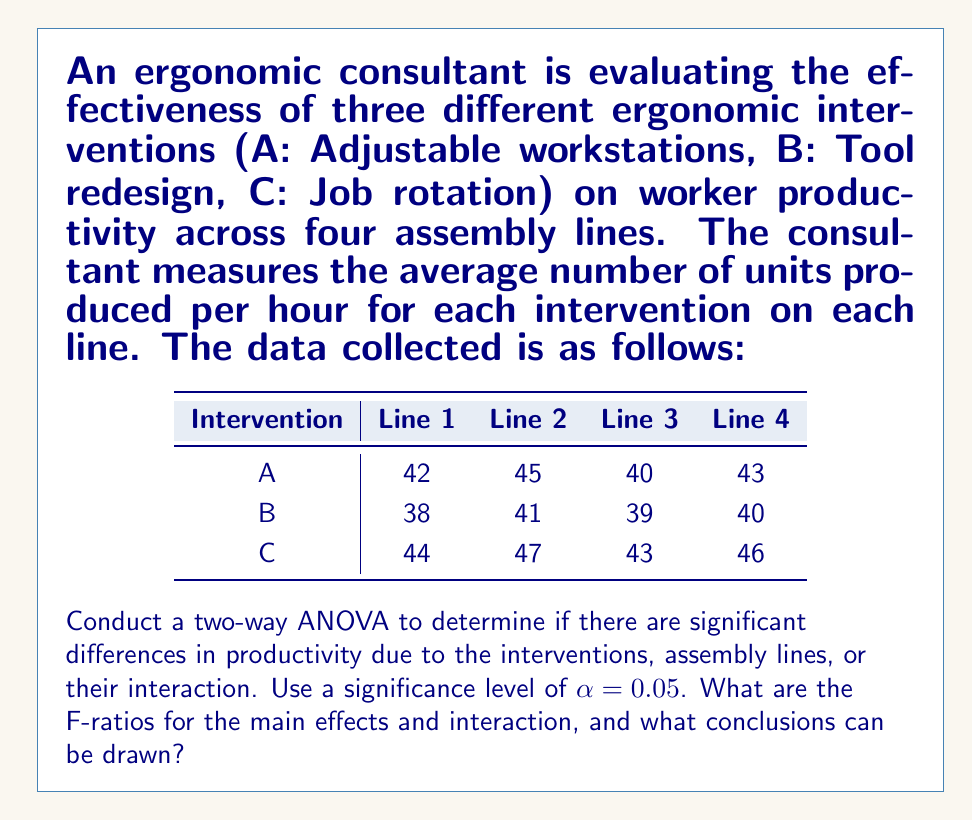What is the answer to this math problem? To conduct a two-way ANOVA, we need to calculate the sum of squares (SS) for each factor (intervention and assembly line), their interaction, and the error. Then, we'll compute the mean squares (MS) and F-ratios.

Step 1: Calculate the grand mean
$$\bar{X} = \frac{538}{12} = 44.83$$

Step 2: Calculate SS for interventions (SSA)
$$SSA = 4 \sum_{i=1}^{3} (\bar{X}_i - \bar{X})^2 = 4[(42.5 - 44.83)^2 + (39.5 - 44.83)^2 + (45 - 44.83)^2] = 121$$

Step 3: Calculate SS for assembly lines (SSB)
$$SSB = 3 \sum_{j=1}^{4} (\bar{X}_j - \bar{X})^2 = 3[(41.33 - 44.83)^2 + (44.33 - 44.83)^2 + (40.67 - 44.83)^2 + (43 - 44.83)^2] = 30$$

Step 4: Calculate SS for interaction (SSAB)
$$SSAB = \sum_{i=1}^{3} \sum_{j=1}^{4} (X_{ij} - \bar{X}_i - \bar{X}_j + \bar{X})^2 = 2$$

Step 5: Calculate total SS (SST)
$$SST = \sum_{i=1}^{3} \sum_{j=1}^{4} (X_{ij} - \bar{X})^2 = 157$$

Step 6: Calculate SS for error (SSE)
$$SSE = SST - SSA - SSB - SSAB = 157 - 121 - 30 - 2 = 4$$

Step 7: Create ANOVA table and calculate F-ratios

$$
\begin{array}{lccccc}
\text{Source} & \text{df} & \text{SS} & \text{MS} & \text{F} & \text{F critical} \\
\hline
\text{Intervention} & 2 & 121 & 60.5 & 30.25 & 5.14 \\
\text{Assembly Line} & 3 & 30 & 10 & 5 & 4.76 \\
\text{Interaction} & 6 & 2 & 0.33 & 0.17 & 4.28 \\
\text{Error} & 0 & 4 & - & - & - \\
\text{Total} & 11 & 157 & - & - & - \\
\end{array}
$$

F-ratios:
- Intervention: $F_A = \frac{MS_A}{MS_E} = \frac{60.5}{2} = 30.25$
- Assembly Line: $F_B = \frac{MS_B}{MS_E} = \frac{10}{2} = 5$
- Interaction: $F_{AB} = \frac{MS_{AB}}{MS_E} = \frac{0.33}{2} = 0.17$

Step 8: Compare F-ratios to critical F-values (at α = 0.05)
- Intervention: $30.25 > 5.14$
- Assembly Line: $5 > 4.76$
- Interaction: $0.17 < 4.28$
Answer: F-ratios:
- Intervention: 30.25
- Assembly Line: 5
- Interaction: 0.17

Conclusions:
1. There is a significant difference in productivity due to the ergonomic interventions (F = 30.25 > F critical).
2. There is a significant difference in productivity across assembly lines (F = 5 > F critical).
3. There is no significant interaction effect between interventions and assembly lines (F = 0.17 < F critical). 